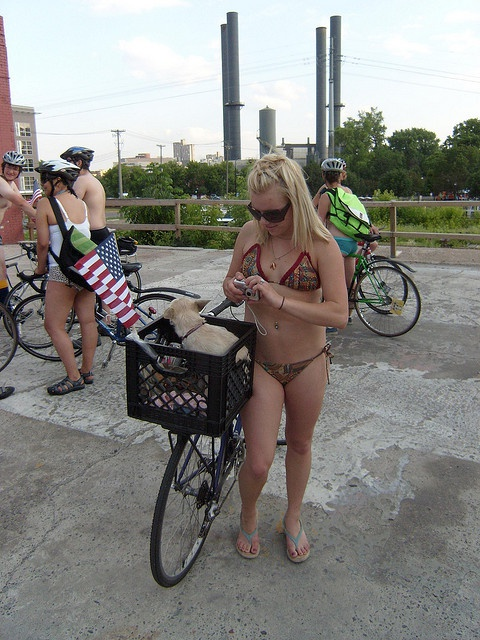Describe the objects in this image and their specific colors. I can see people in white, brown, gray, and maroon tones, bicycle in white, black, gray, and darkgray tones, people in white, brown, gray, black, and maroon tones, bicycle in white, black, gray, and darkgray tones, and bicycle in white, gray, darkgray, black, and teal tones in this image. 